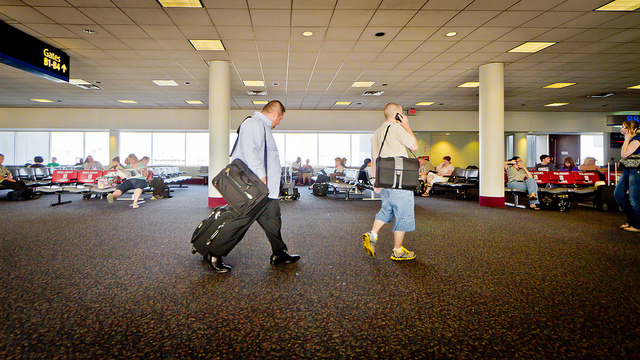<image>Which light is not on? It is ambiguous which light is not on. It could be the center top, center ceiling, center spotlight, or middle circle. Which light is not on? I don't know which light is not on. It can be any of them. 